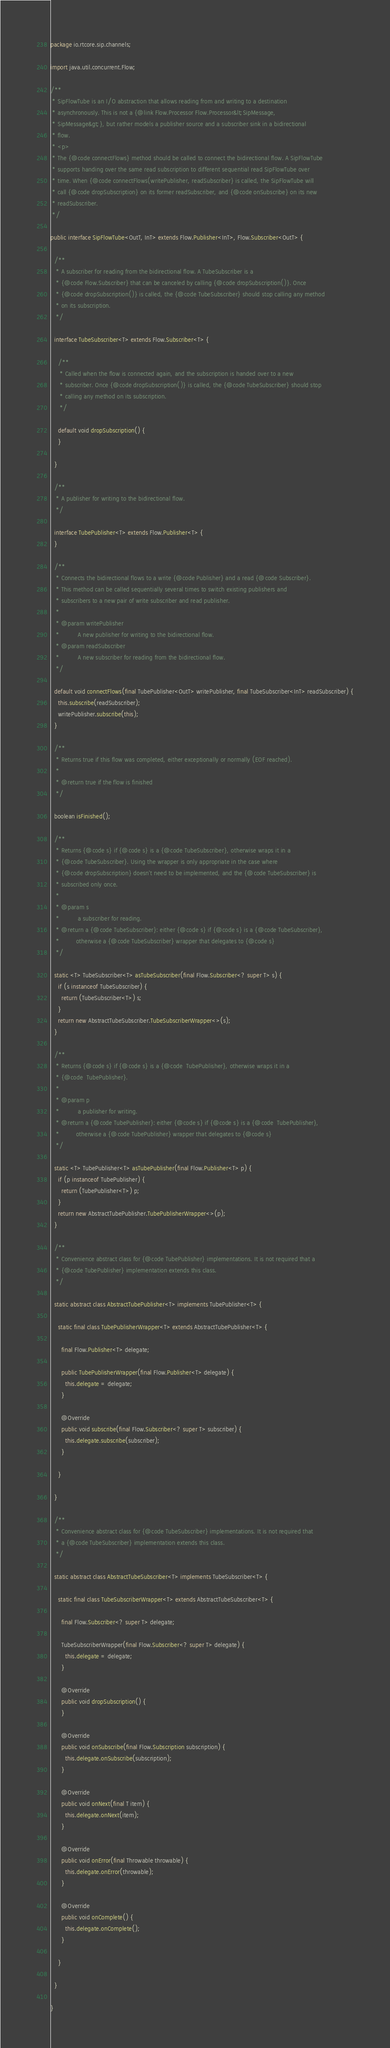<code> <loc_0><loc_0><loc_500><loc_500><_Java_>package io.rtcore.sip.channels;

import java.util.concurrent.Flow;

/**
 * SipFlowTube is an I/O abstraction that allows reading from and writing to a destination
 * asynchronously. This is not a {@link Flow.Processor Flow.Processor&lt;SipMessage,
 * SipMessage&gt;}, but rather models a publisher source and a subscriber sink in a bidirectional
 * flow.
 * <p>
 * The {@code connectFlows} method should be called to connect the bidirectional flow. A SipFlowTube
 * supports handing over the same read subscription to different sequential read SipFlowTube over
 * time. When {@code connectFlows(writePublisher, readSubscriber} is called, the SipFlowTube will
 * call {@code dropSubscription} on its former readSubscriber, and {@code onSubscribe} on its new
 * readSubscriber.
 */

public interface SipFlowTube<OutT, InT> extends Flow.Publisher<InT>, Flow.Subscriber<OutT> {

  /**
   * A subscriber for reading from the bidirectional flow. A TubeSubscriber is a
   * {@code Flow.Subscriber} that can be canceled by calling {@code dropSubscription()}. Once
   * {@code dropSubscription()} is called, the {@code TubeSubscriber} should stop calling any method
   * on its subscription.
   */

  interface TubeSubscriber<T> extends Flow.Subscriber<T> {

    /**
     * Called when the flow is connected again, and the subscription is handed over to a new
     * subscriber. Once {@code dropSubscription()} is called, the {@code TubeSubscriber} should stop
     * calling any method on its subscription.
     */

    default void dropSubscription() {
    }

  }

  /**
   * A publisher for writing to the bidirectional flow.
   */

  interface TubePublisher<T> extends Flow.Publisher<T> {
  }

  /**
   * Connects the bidirectional flows to a write {@code Publisher} and a read {@code Subscriber}.
   * This method can be called sequentially several times to switch existing publishers and
   * subscribers to a new pair of write subscriber and read publisher.
   *
   * @param writePublisher
   *          A new publisher for writing to the bidirectional flow.
   * @param readSubscriber
   *          A new subscriber for reading from the bidirectional flow.
   */

  default void connectFlows(final TubePublisher<OutT> writePublisher, final TubeSubscriber<InT> readSubscriber) {
    this.subscribe(readSubscriber);
    writePublisher.subscribe(this);
  }

  /**
   * Returns true if this flow was completed, either exceptionally or normally (EOF reached).
   *
   * @return true if the flow is finished
   */

  boolean isFinished();

  /**
   * Returns {@code s} if {@code s} is a {@code TubeSubscriber}, otherwise wraps it in a
   * {@code TubeSubscriber}. Using the wrapper is only appropriate in the case where
   * {@code dropSubscription} doesn't need to be implemented, and the {@code TubeSubscriber} is
   * subscribed only once.
   *
   * @param s
   *          a subscriber for reading.
   * @return a {@code TubeSubscriber}: either {@code s} if {@code s} is a {@code TubeSubscriber},
   *         otherwise a {@code TubeSubscriber} wrapper that delegates to {@code s}
   */

  static <T> TubeSubscriber<T> asTubeSubscriber(final Flow.Subscriber<? super T> s) {
    if (s instanceof TubeSubscriber) {
      return (TubeSubscriber<T>) s;
    }
    return new AbstractTubeSubscriber.TubeSubscriberWrapper<>(s);
  }

  /**
   * Returns {@code s} if {@code s} is a {@code  TubePublisher}, otherwise wraps it in a
   * {@code  TubePublisher}.
   *
   * @param p
   *          a publisher for writing.
   * @return a {@code TubePublisher}: either {@code s} if {@code s} is a {@code  TubePublisher},
   *         otherwise a {@code TubePublisher} wrapper that delegates to {@code s}
   */

  static <T> TubePublisher<T> asTubePublisher(final Flow.Publisher<T> p) {
    if (p instanceof TubePublisher) {
      return (TubePublisher<T>) p;
    }
    return new AbstractTubePublisher.TubePublisherWrapper<>(p);
  }

  /**
   * Convenience abstract class for {@code TubePublisher} implementations. It is not required that a
   * {@code TubePublisher} implementation extends this class.
   */

  static abstract class AbstractTubePublisher<T> implements TubePublisher<T> {

    static final class TubePublisherWrapper<T> extends AbstractTubePublisher<T> {

      final Flow.Publisher<T> delegate;

      public TubePublisherWrapper(final Flow.Publisher<T> delegate) {
        this.delegate = delegate;
      }

      @Override
      public void subscribe(final Flow.Subscriber<? super T> subscriber) {
        this.delegate.subscribe(subscriber);
      }

    }

  }

  /**
   * Convenience abstract class for {@code TubeSubscriber} implementations. It is not required that
   * a {@code TubeSubscriber} implementation extends this class.
   */

  static abstract class AbstractTubeSubscriber<T> implements TubeSubscriber<T> {

    static final class TubeSubscriberWrapper<T> extends AbstractTubeSubscriber<T> {

      final Flow.Subscriber<? super T> delegate;

      TubeSubscriberWrapper(final Flow.Subscriber<? super T> delegate) {
        this.delegate = delegate;
      }

      @Override
      public void dropSubscription() {
      }

      @Override
      public void onSubscribe(final Flow.Subscription subscription) {
        this.delegate.onSubscribe(subscription);
      }

      @Override
      public void onNext(final T item) {
        this.delegate.onNext(item);
      }

      @Override
      public void onError(final Throwable throwable) {
        this.delegate.onError(throwable);
      }

      @Override
      public void onComplete() {
        this.delegate.onComplete();
      }

    }

  }

}
</code> 